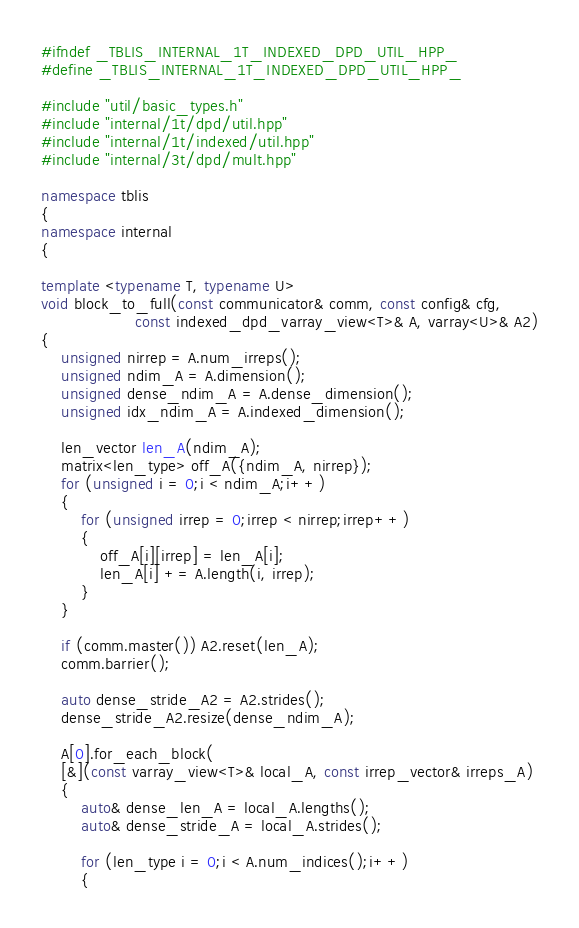<code> <loc_0><loc_0><loc_500><loc_500><_C++_>#ifndef _TBLIS_INTERNAL_1T_INDEXED_DPD_UTIL_HPP_
#define _TBLIS_INTERNAL_1T_INDEXED_DPD_UTIL_HPP_

#include "util/basic_types.h"
#include "internal/1t/dpd/util.hpp"
#include "internal/1t/indexed/util.hpp"
#include "internal/3t/dpd/mult.hpp"

namespace tblis
{
namespace internal
{

template <typename T, typename U>
void block_to_full(const communicator& comm, const config& cfg,
                   const indexed_dpd_varray_view<T>& A, varray<U>& A2)
{
    unsigned nirrep = A.num_irreps();
    unsigned ndim_A = A.dimension();
    unsigned dense_ndim_A = A.dense_dimension();
    unsigned idx_ndim_A = A.indexed_dimension();

    len_vector len_A(ndim_A);
    matrix<len_type> off_A({ndim_A, nirrep});
    for (unsigned i = 0;i < ndim_A;i++)
    {
        for (unsigned irrep = 0;irrep < nirrep;irrep++)
        {
            off_A[i][irrep] = len_A[i];
            len_A[i] += A.length(i, irrep);
        }
    }

    if (comm.master()) A2.reset(len_A);
    comm.barrier();

    auto dense_stride_A2 = A2.strides();
    dense_stride_A2.resize(dense_ndim_A);

    A[0].for_each_block(
    [&](const varray_view<T>& local_A, const irrep_vector& irreps_A)
    {
        auto& dense_len_A = local_A.lengths();
        auto& dense_stride_A = local_A.strides();

        for (len_type i = 0;i < A.num_indices();i++)
        {</code> 